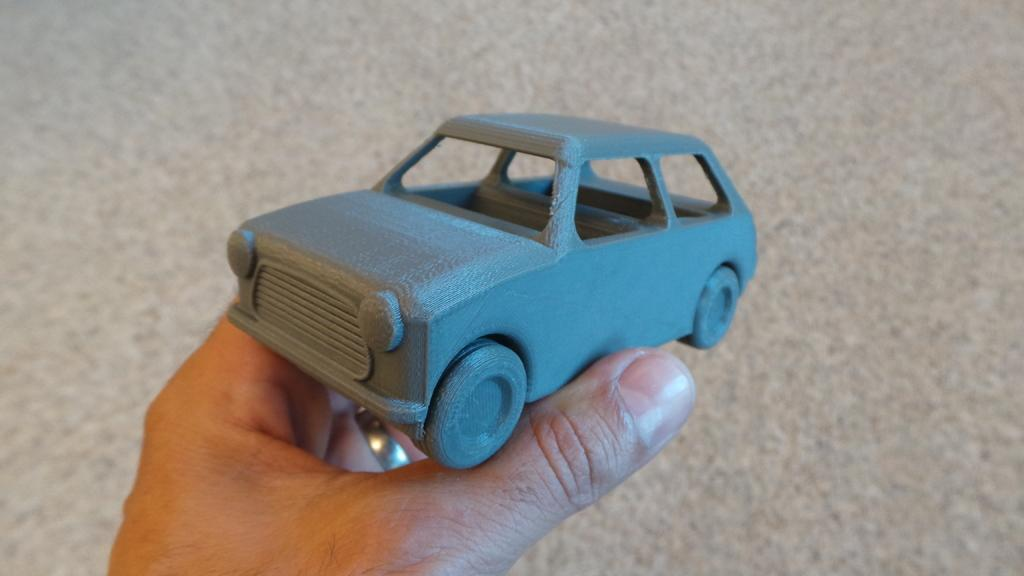What can be seen in the picture? There is a person's hand in the picture. What is the person holding? The person is holding a toy car. What color is the toy car? The toy car is blue in color. What type of corn is being harvested in the background of the image? There is no corn or background visible in the image; it only shows a person's hand holding a blue toy car. 